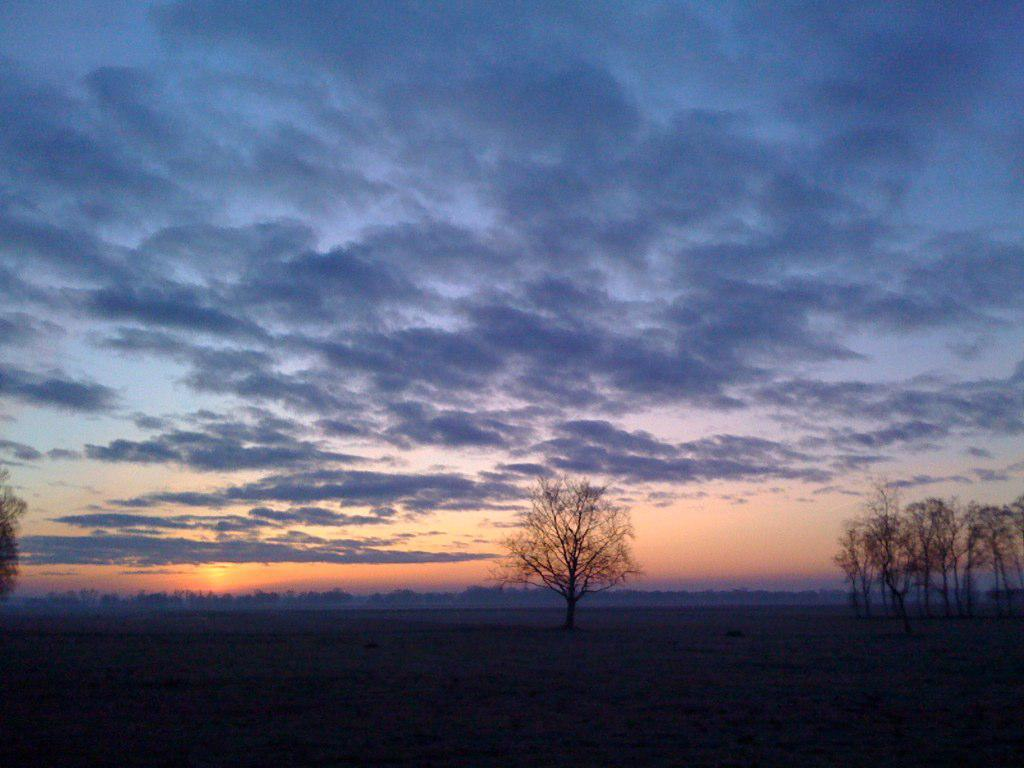What type of vegetation can be seen in the image? There are trees in the image. What part of the natural environment is visible in the image? The sky is visible in the image. Can you describe the condition of the sky in the image? The sky is cloudy in the image. How many buns are visible in the image? There are no buns present in the image. What type of marble is used to decorate the trees in the image? There is no marble used to decorate the trees in the image; they are natural vegetation. 